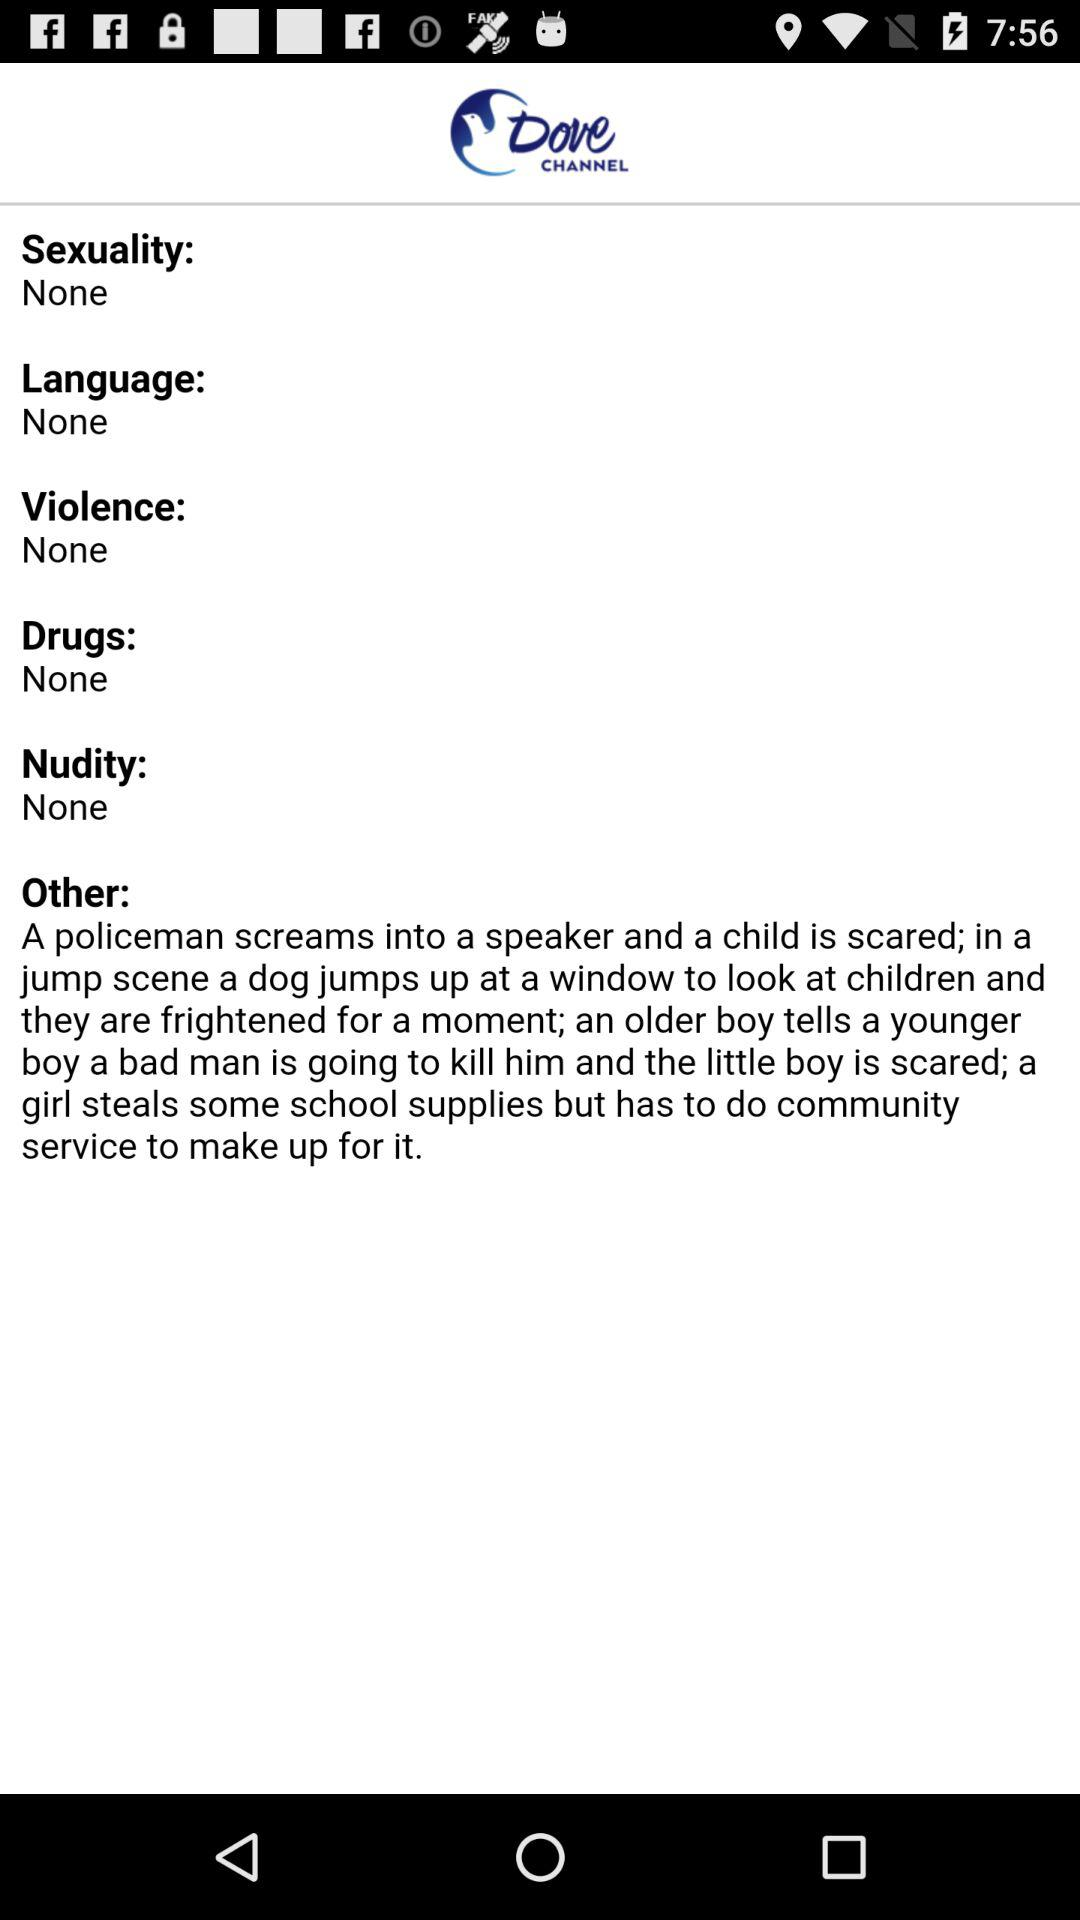What is the selected language? The selected language is none. 